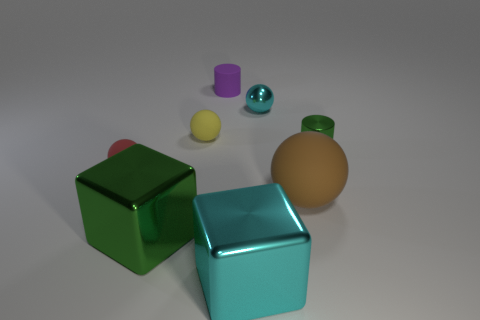Do the green object that is in front of the brown ball and the brown object have the same material?
Your response must be concise. No. How many things are either big purple balls or objects that are to the right of the large brown thing?
Your answer should be very brief. 1. How many big brown things are behind the cylinder on the right side of the ball in front of the red object?
Provide a succinct answer. 0. Is the shape of the tiny shiny object on the left side of the large brown matte sphere the same as  the yellow thing?
Keep it short and to the point. Yes. Are there any small metallic balls right of the green metallic object that is in front of the small metallic cylinder?
Provide a short and direct response. Yes. What number of small purple metal cylinders are there?
Offer a very short reply. 0. What is the color of the object that is both left of the purple object and in front of the big sphere?
Give a very brief answer. Green. There is a red rubber thing that is the same shape as the small yellow rubber object; what is its size?
Make the answer very short. Small. How many other cylinders are the same size as the metallic cylinder?
Ensure brevity in your answer.  1. What material is the large brown sphere?
Your response must be concise. Rubber. 